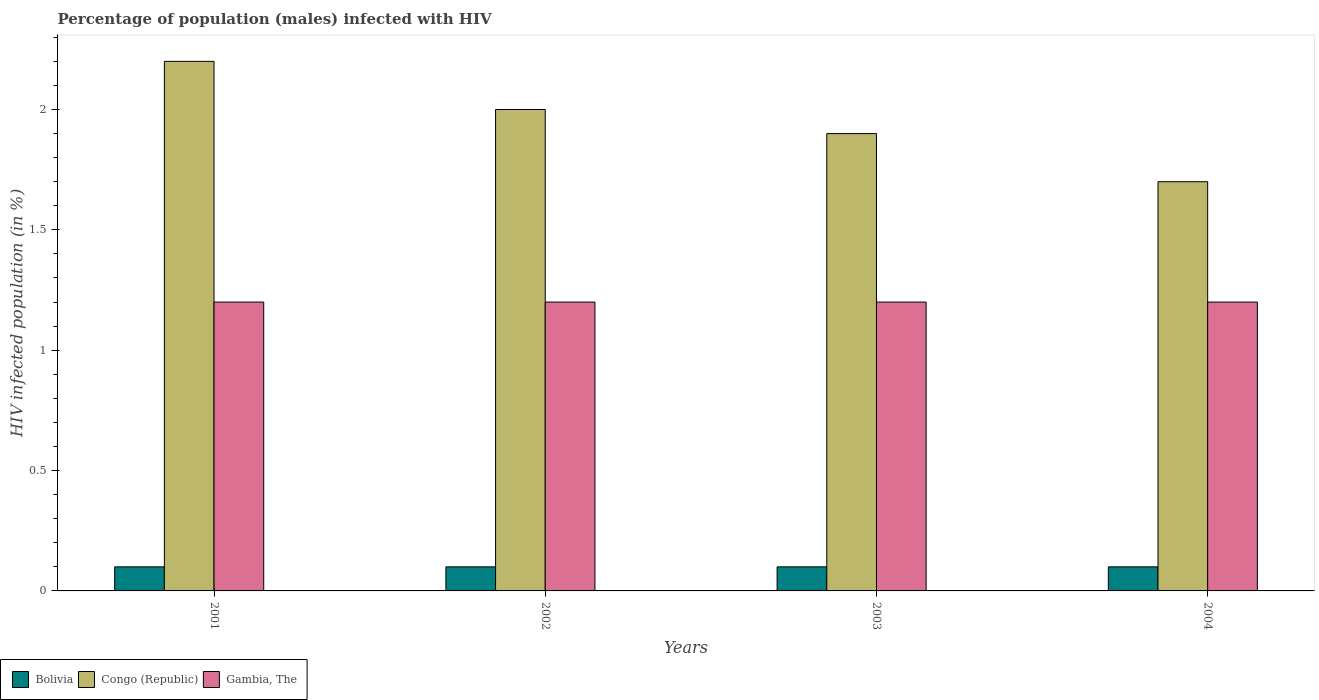How many groups of bars are there?
Ensure brevity in your answer.  4. What is the label of the 1st group of bars from the left?
Your response must be concise. 2001. What is the percentage of HIV infected male population in Congo (Republic) in 2001?
Your answer should be compact. 2.2. Across all years, what is the maximum percentage of HIV infected male population in Bolivia?
Provide a short and direct response. 0.1. In which year was the percentage of HIV infected male population in Bolivia maximum?
Give a very brief answer. 2001. What is the total percentage of HIV infected male population in Gambia, The in the graph?
Offer a very short reply. 4.8. What is the difference between the percentage of HIV infected male population in Bolivia in 2001 and that in 2002?
Provide a short and direct response. 0. What is the average percentage of HIV infected male population in Congo (Republic) per year?
Your answer should be compact. 1.95. In the year 2003, what is the difference between the percentage of HIV infected male population in Bolivia and percentage of HIV infected male population in Congo (Republic)?
Your answer should be compact. -1.8. In how many years, is the percentage of HIV infected male population in Gambia, The greater than 1.1 %?
Your answer should be compact. 4. What is the ratio of the percentage of HIV infected male population in Gambia, The in 2001 to that in 2004?
Your response must be concise. 1. Is the difference between the percentage of HIV infected male population in Bolivia in 2001 and 2004 greater than the difference between the percentage of HIV infected male population in Congo (Republic) in 2001 and 2004?
Offer a terse response. No. What is the difference between the highest and the second highest percentage of HIV infected male population in Congo (Republic)?
Your response must be concise. 0.2. What is the difference between the highest and the lowest percentage of HIV infected male population in Bolivia?
Keep it short and to the point. 0. What does the 2nd bar from the left in 2004 represents?
Keep it short and to the point. Congo (Republic). What does the 3rd bar from the right in 2001 represents?
Your answer should be compact. Bolivia. Are all the bars in the graph horizontal?
Provide a short and direct response. No. How many years are there in the graph?
Provide a short and direct response. 4. Does the graph contain any zero values?
Provide a short and direct response. No. How are the legend labels stacked?
Offer a very short reply. Horizontal. What is the title of the graph?
Provide a succinct answer. Percentage of population (males) infected with HIV. What is the label or title of the X-axis?
Offer a very short reply. Years. What is the label or title of the Y-axis?
Provide a succinct answer. HIV infected population (in %). What is the HIV infected population (in %) in Bolivia in 2001?
Your answer should be very brief. 0.1. What is the HIV infected population (in %) of Bolivia in 2002?
Your response must be concise. 0.1. What is the HIV infected population (in %) of Bolivia in 2003?
Ensure brevity in your answer.  0.1. Across all years, what is the maximum HIV infected population (in %) in Gambia, The?
Ensure brevity in your answer.  1.2. Across all years, what is the minimum HIV infected population (in %) in Congo (Republic)?
Give a very brief answer. 1.7. Across all years, what is the minimum HIV infected population (in %) in Gambia, The?
Give a very brief answer. 1.2. What is the total HIV infected population (in %) of Bolivia in the graph?
Make the answer very short. 0.4. What is the total HIV infected population (in %) in Congo (Republic) in the graph?
Your response must be concise. 7.8. What is the difference between the HIV infected population (in %) of Bolivia in 2001 and that in 2002?
Ensure brevity in your answer.  0. What is the difference between the HIV infected population (in %) in Bolivia in 2001 and that in 2004?
Your answer should be very brief. 0. What is the difference between the HIV infected population (in %) of Gambia, The in 2001 and that in 2004?
Your response must be concise. 0. What is the difference between the HIV infected population (in %) of Bolivia in 2002 and that in 2003?
Your answer should be very brief. 0. What is the difference between the HIV infected population (in %) in Congo (Republic) in 2002 and that in 2003?
Offer a very short reply. 0.1. What is the difference between the HIV infected population (in %) in Gambia, The in 2002 and that in 2003?
Keep it short and to the point. 0. What is the difference between the HIV infected population (in %) of Congo (Republic) in 2002 and that in 2004?
Your answer should be compact. 0.3. What is the difference between the HIV infected population (in %) in Gambia, The in 2002 and that in 2004?
Keep it short and to the point. 0. What is the difference between the HIV infected population (in %) in Bolivia in 2003 and that in 2004?
Offer a terse response. 0. What is the difference between the HIV infected population (in %) in Congo (Republic) in 2003 and that in 2004?
Provide a succinct answer. 0.2. What is the difference between the HIV infected population (in %) in Bolivia in 2001 and the HIV infected population (in %) in Congo (Republic) in 2002?
Offer a terse response. -1.9. What is the difference between the HIV infected population (in %) of Bolivia in 2001 and the HIV infected population (in %) of Gambia, The in 2002?
Your response must be concise. -1.1. What is the difference between the HIV infected population (in %) in Congo (Republic) in 2001 and the HIV infected population (in %) in Gambia, The in 2002?
Offer a very short reply. 1. What is the difference between the HIV infected population (in %) in Congo (Republic) in 2001 and the HIV infected population (in %) in Gambia, The in 2003?
Keep it short and to the point. 1. What is the difference between the HIV infected population (in %) of Congo (Republic) in 2001 and the HIV infected population (in %) of Gambia, The in 2004?
Make the answer very short. 1. What is the difference between the HIV infected population (in %) of Bolivia in 2002 and the HIV infected population (in %) of Gambia, The in 2003?
Offer a very short reply. -1.1. What is the difference between the HIV infected population (in %) of Bolivia in 2002 and the HIV infected population (in %) of Congo (Republic) in 2004?
Your answer should be very brief. -1.6. What is the difference between the HIV infected population (in %) of Bolivia in 2002 and the HIV infected population (in %) of Gambia, The in 2004?
Your response must be concise. -1.1. What is the difference between the HIV infected population (in %) of Bolivia in 2003 and the HIV infected population (in %) of Congo (Republic) in 2004?
Give a very brief answer. -1.6. What is the difference between the HIV infected population (in %) in Bolivia in 2003 and the HIV infected population (in %) in Gambia, The in 2004?
Give a very brief answer. -1.1. What is the difference between the HIV infected population (in %) of Congo (Republic) in 2003 and the HIV infected population (in %) of Gambia, The in 2004?
Offer a terse response. 0.7. What is the average HIV infected population (in %) in Bolivia per year?
Offer a terse response. 0.1. What is the average HIV infected population (in %) in Congo (Republic) per year?
Offer a terse response. 1.95. In the year 2001, what is the difference between the HIV infected population (in %) in Bolivia and HIV infected population (in %) in Congo (Republic)?
Offer a very short reply. -2.1. In the year 2001, what is the difference between the HIV infected population (in %) in Bolivia and HIV infected population (in %) in Gambia, The?
Offer a terse response. -1.1. In the year 2003, what is the difference between the HIV infected population (in %) in Bolivia and HIV infected population (in %) in Congo (Republic)?
Your answer should be compact. -1.8. In the year 2003, what is the difference between the HIV infected population (in %) of Bolivia and HIV infected population (in %) of Gambia, The?
Give a very brief answer. -1.1. In the year 2003, what is the difference between the HIV infected population (in %) in Congo (Republic) and HIV infected population (in %) in Gambia, The?
Offer a terse response. 0.7. In the year 2004, what is the difference between the HIV infected population (in %) of Bolivia and HIV infected population (in %) of Congo (Republic)?
Provide a succinct answer. -1.6. In the year 2004, what is the difference between the HIV infected population (in %) in Congo (Republic) and HIV infected population (in %) in Gambia, The?
Give a very brief answer. 0.5. What is the ratio of the HIV infected population (in %) of Congo (Republic) in 2001 to that in 2002?
Offer a terse response. 1.1. What is the ratio of the HIV infected population (in %) of Congo (Republic) in 2001 to that in 2003?
Offer a terse response. 1.16. What is the ratio of the HIV infected population (in %) of Gambia, The in 2001 to that in 2003?
Your response must be concise. 1. What is the ratio of the HIV infected population (in %) of Bolivia in 2001 to that in 2004?
Your answer should be very brief. 1. What is the ratio of the HIV infected population (in %) in Congo (Republic) in 2001 to that in 2004?
Ensure brevity in your answer.  1.29. What is the ratio of the HIV infected population (in %) in Bolivia in 2002 to that in 2003?
Your answer should be compact. 1. What is the ratio of the HIV infected population (in %) of Congo (Republic) in 2002 to that in 2003?
Give a very brief answer. 1.05. What is the ratio of the HIV infected population (in %) of Bolivia in 2002 to that in 2004?
Provide a succinct answer. 1. What is the ratio of the HIV infected population (in %) in Congo (Republic) in 2002 to that in 2004?
Offer a terse response. 1.18. What is the ratio of the HIV infected population (in %) in Gambia, The in 2002 to that in 2004?
Your answer should be very brief. 1. What is the ratio of the HIV infected population (in %) of Congo (Republic) in 2003 to that in 2004?
Your answer should be compact. 1.12. What is the ratio of the HIV infected population (in %) in Gambia, The in 2003 to that in 2004?
Your answer should be very brief. 1. What is the difference between the highest and the second highest HIV infected population (in %) of Bolivia?
Offer a terse response. 0. What is the difference between the highest and the second highest HIV infected population (in %) of Congo (Republic)?
Offer a very short reply. 0.2. What is the difference between the highest and the lowest HIV infected population (in %) of Bolivia?
Offer a terse response. 0. What is the difference between the highest and the lowest HIV infected population (in %) in Congo (Republic)?
Give a very brief answer. 0.5. 